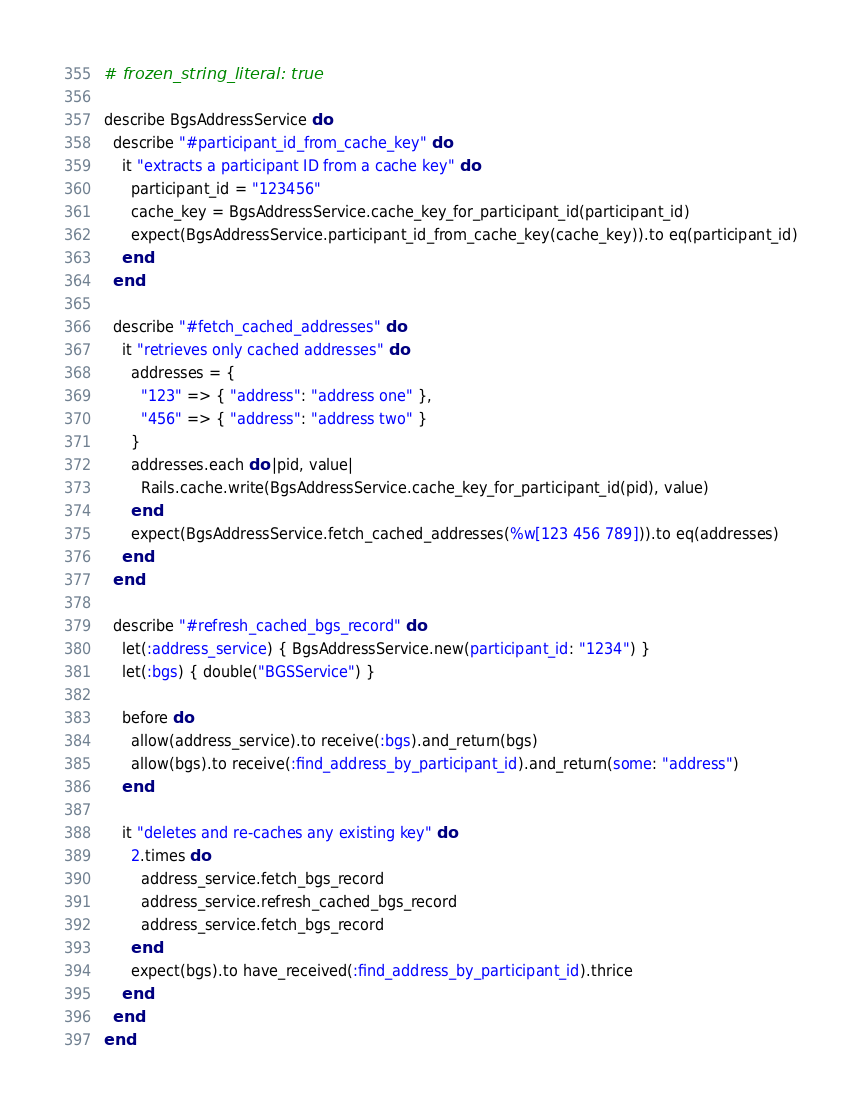<code> <loc_0><loc_0><loc_500><loc_500><_Ruby_># frozen_string_literal: true

describe BgsAddressService do
  describe "#participant_id_from_cache_key" do
    it "extracts a participant ID from a cache key" do
      participant_id = "123456"
      cache_key = BgsAddressService.cache_key_for_participant_id(participant_id)
      expect(BgsAddressService.participant_id_from_cache_key(cache_key)).to eq(participant_id)
    end
  end

  describe "#fetch_cached_addresses" do
    it "retrieves only cached addresses" do
      addresses = {
        "123" => { "address": "address one" },
        "456" => { "address": "address two" }
      }
      addresses.each do |pid, value|
        Rails.cache.write(BgsAddressService.cache_key_for_participant_id(pid), value)
      end
      expect(BgsAddressService.fetch_cached_addresses(%w[123 456 789])).to eq(addresses)
    end
  end

  describe "#refresh_cached_bgs_record" do
    let(:address_service) { BgsAddressService.new(participant_id: "1234") }
    let(:bgs) { double("BGSService") }

    before do
      allow(address_service).to receive(:bgs).and_return(bgs)
      allow(bgs).to receive(:find_address_by_participant_id).and_return(some: "address")
    end

    it "deletes and re-caches any existing key" do
      2.times do
        address_service.fetch_bgs_record
        address_service.refresh_cached_bgs_record
        address_service.fetch_bgs_record
      end
      expect(bgs).to have_received(:find_address_by_participant_id).thrice
    end
  end
end
</code> 